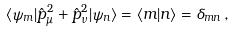Convert formula to latex. <formula><loc_0><loc_0><loc_500><loc_500>\langle \psi _ { m } | \hat { p } _ { \mu } ^ { 2 } + \hat { p } _ { \nu } ^ { 2 } | \psi _ { n } \rangle = \langle m | n \rangle = \delta _ { m n } \, ,</formula> 